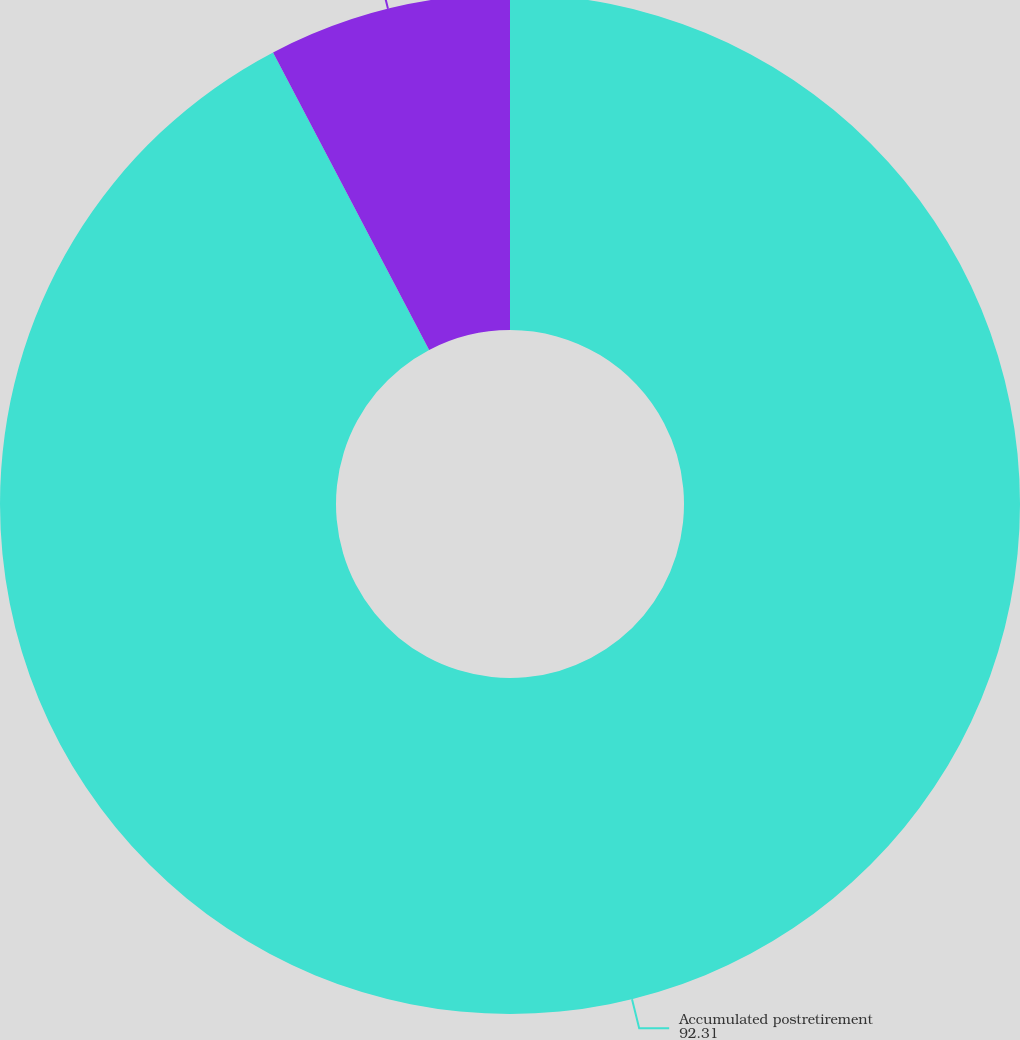<chart> <loc_0><loc_0><loc_500><loc_500><pie_chart><fcel>Accumulated postretirement<fcel>Total of service and interest<nl><fcel>92.31%<fcel>7.69%<nl></chart> 